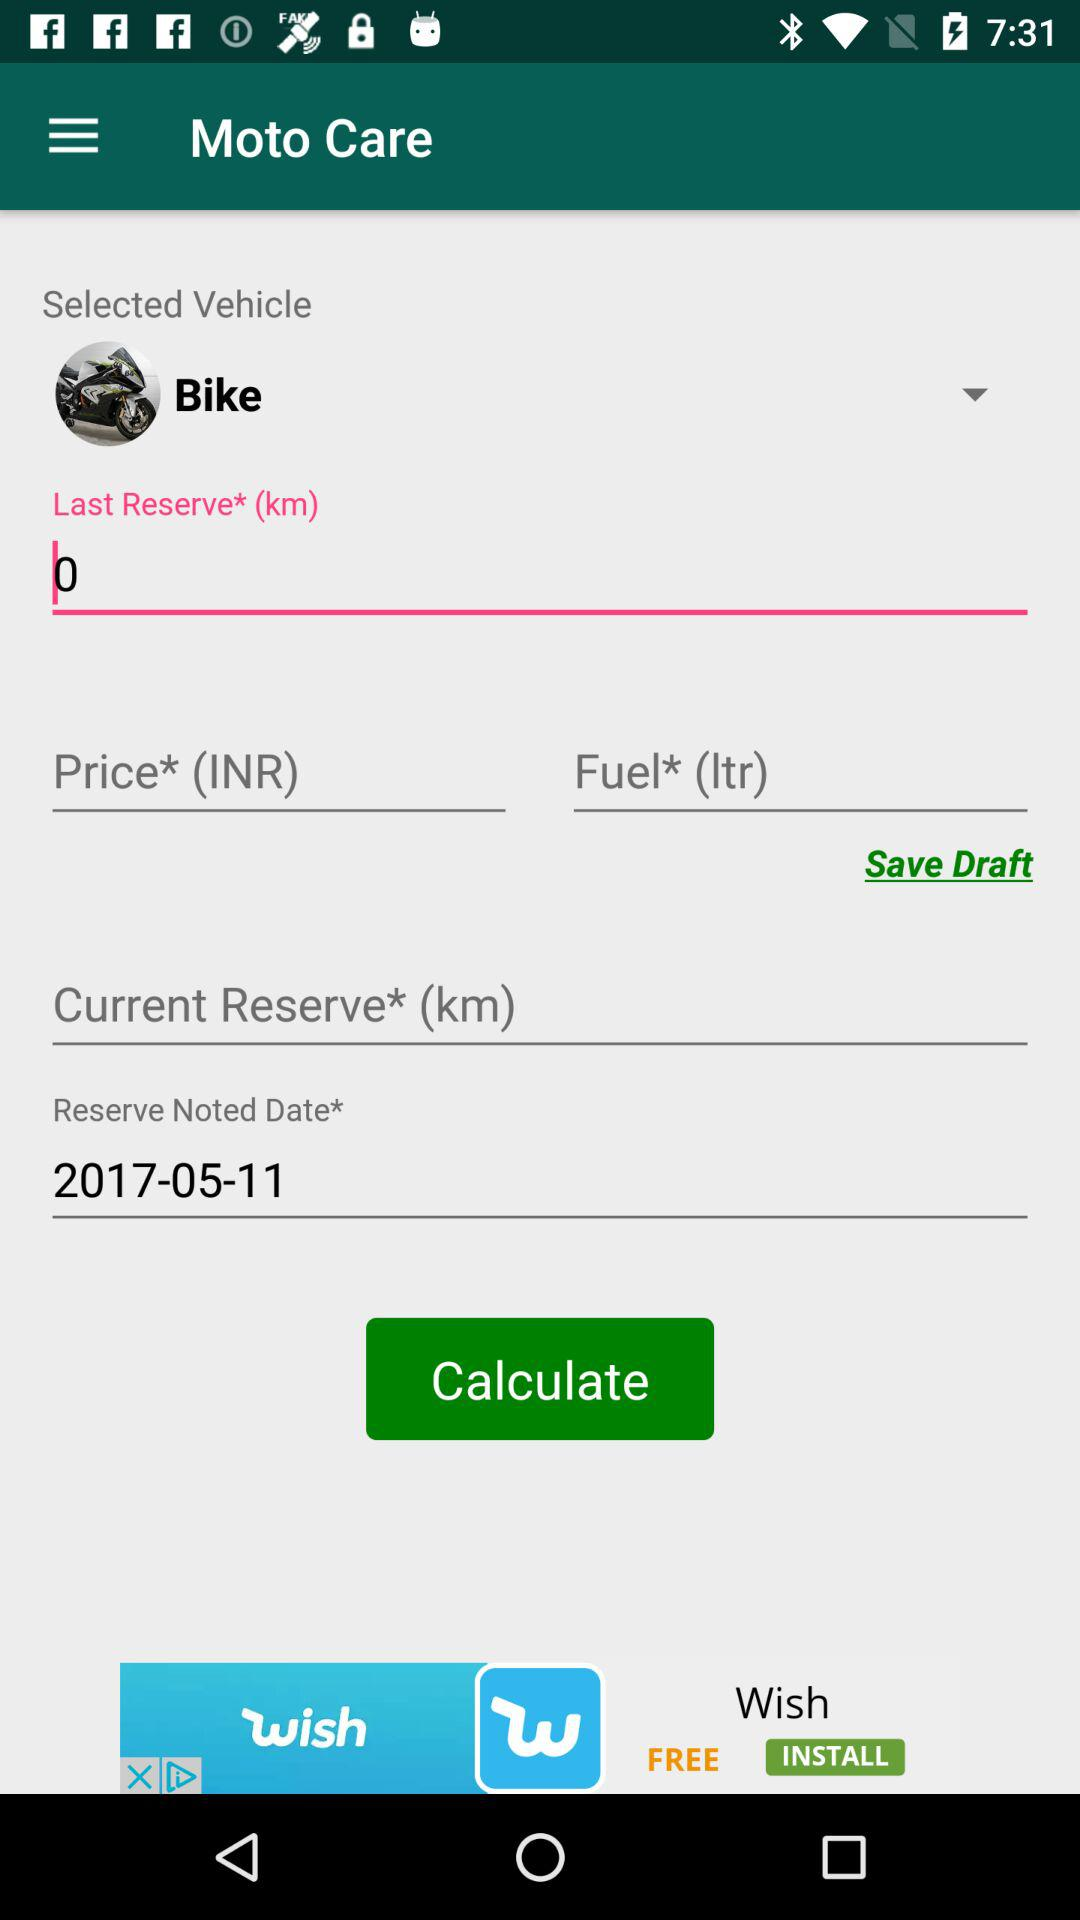What is the last reserve in km? The last reserve is 0 km. 